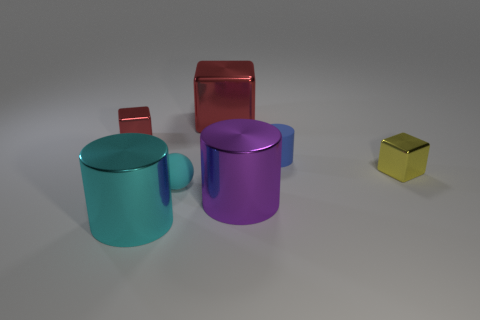There is a tiny metal thing behind the rubber cylinder; is it the same shape as the large shiny object behind the blue object?
Give a very brief answer. Yes. How many things are either yellow metallic things or small things to the left of the small blue thing?
Your answer should be very brief. 3. How many other things are the same shape as the small cyan thing?
Provide a short and direct response. 0. Is the material of the small cube that is left of the small yellow metal block the same as the small cyan ball?
Offer a very short reply. No. What number of things are either brown metallic cylinders or red cubes?
Your response must be concise. 2. There is a yellow metallic thing that is the same shape as the tiny red thing; what is its size?
Give a very brief answer. Small. The purple cylinder has what size?
Offer a very short reply. Large. Is the number of small yellow objects right of the yellow metal object greater than the number of big metallic cylinders?
Offer a terse response. No. Is there anything else that has the same material as the small ball?
Offer a very short reply. Yes. There is a rubber object that is behind the tiny matte sphere; is its color the same as the large thing that is in front of the purple shiny cylinder?
Your answer should be very brief. No. 